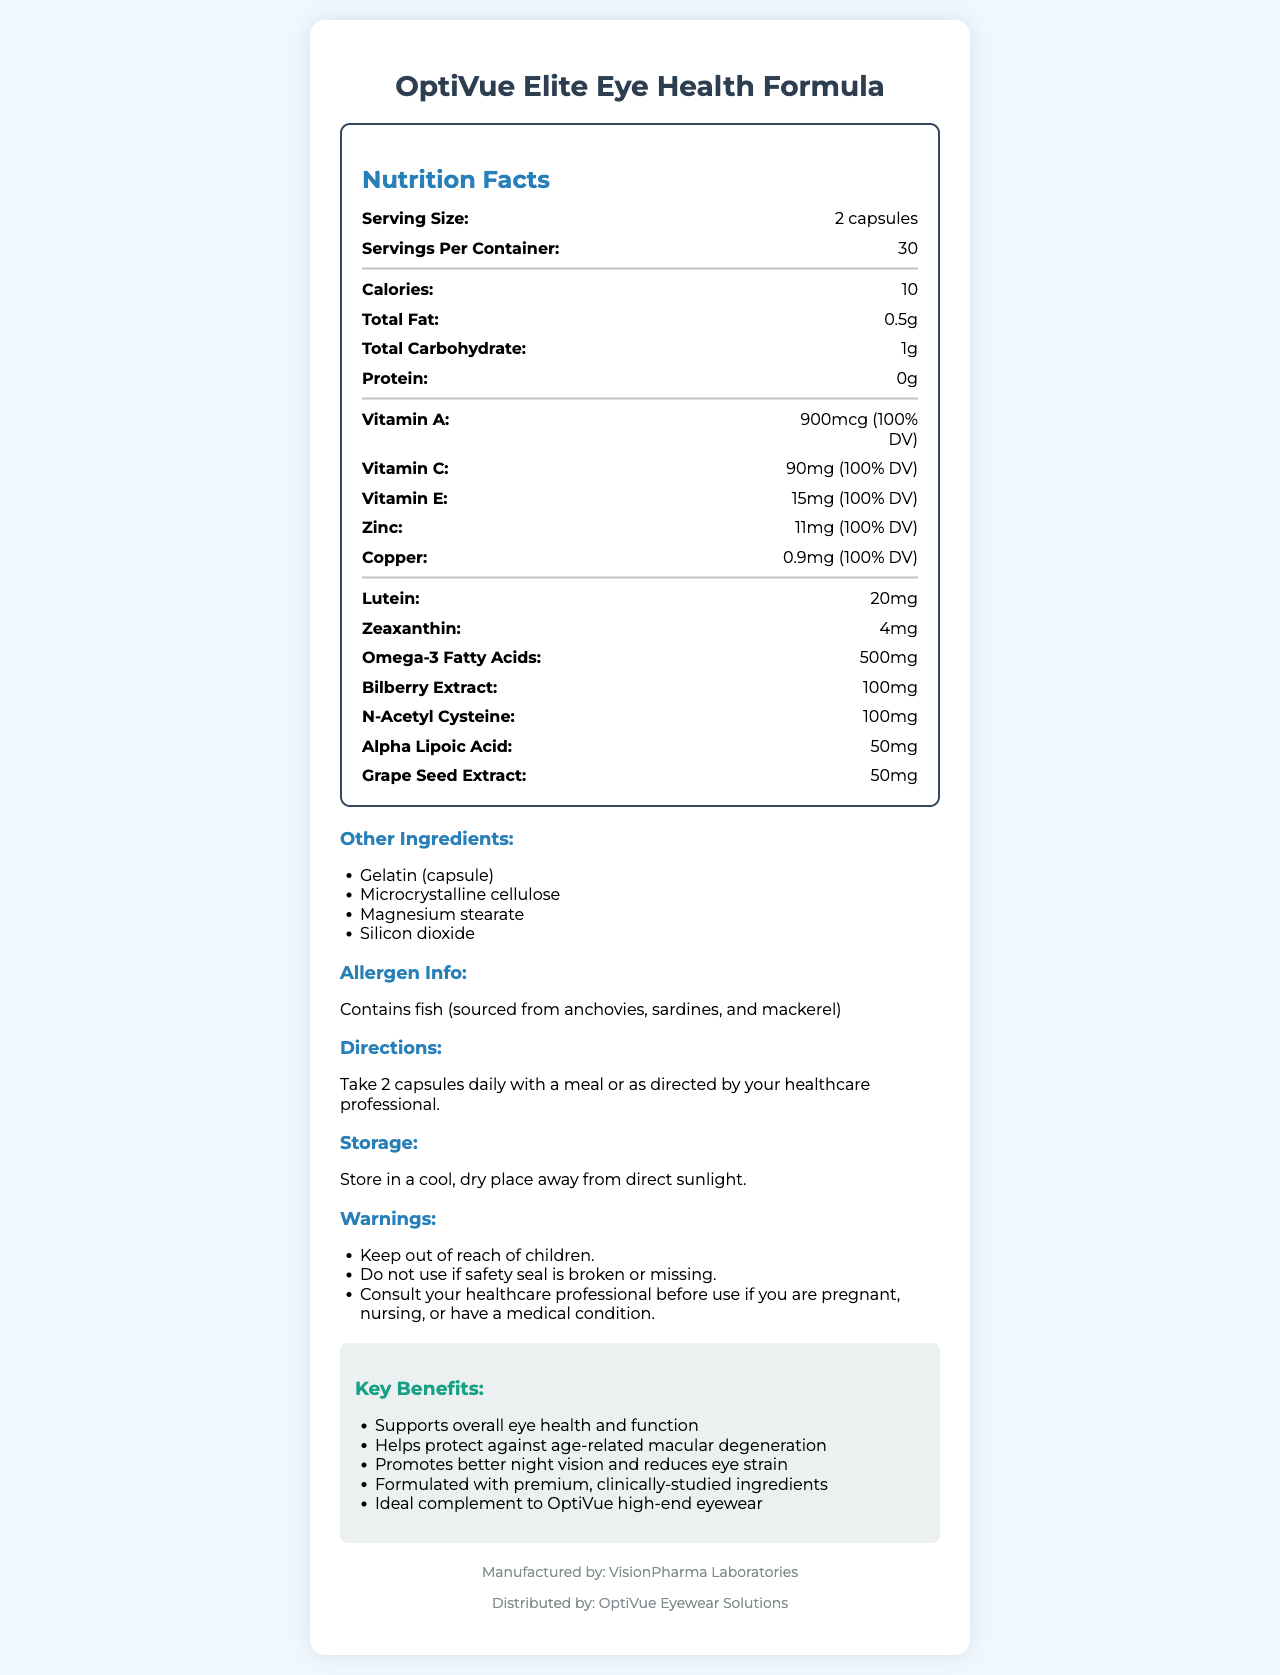what is the serving size? The document states that the serving size for OptiVue Elite Eye Health Formula is 2 capsules.
Answer: 2 capsules how many servings are in a container? According to the document, there are 30 servings per container of OptiVue Elite Eye Health Formula.
Answer: 30 what is the total amount of omega-3 fatty acids per serving? The nutrition facts mention that each serving contains 500mg of omega-3 fatty acids.
Answer: 500mg how many calories are in a serving? The document specifies that there are 10 calories per serving.
Answer: 10 what percentage of the Daily Value does the Vitamin A content represent? The document lists the Vitamin A content as 900mcg, which is 100% of the Daily Value.
Answer: 100% which ingredients are specifically associated with eye health in the product? The ingredients specifically associated with eye health listed in the document are Lutein (20mg) and Zeaxanthin (4mg).
Answer: Lutein, Zeaxanthin which vitamin has the highest amount per serving in milligrams? Vitamin C has 90mg per serving, which is the highest amount compared to the other vitamins listed.
Answer: Vitamin C what are the directions for using this supplement? The document indicates that the users should take 2 capsules daily with a meal or as directed by their healthcare professional.
Answer: Take 2 capsules daily with a meal or as directed by your healthcare professional. what is the main allergen present in the product? The allergen information section states that the product contains fish, sourced from anchovies, sardines, and mackerel.
Answer: Fish (sourced from anchovies, sardines, and mackerel) summarize the key benefits of the OptiVue Elite Eye Health Formula. The key benefits listed in the document demonstrate that this supplement supports overall eye health, helps protect against age-related macular degeneration, promotes better night vision, reduces eye strain, and is formulated with premium ingredients.
Answer: Supports overall eye health and function, helps protect against age-related macular degeneration, promotes better night vision and reduces eye strain, formulated with premium, clinically-studied ingredients, ideal complement to OptiVue high-end eyewear who manufactures the OptiVue Elite Eye Health Formula? The footer of the document states that VisionPharma Laboratories manufactures the product.
Answer: VisionPharma Laboratories what other ingredients are included in this supplement (excluding main nutrients and key ingredients)? The "Other Ingredients" section lists Gelatin (capsule), Microcrystalline cellulose, Magnesium stearate, and Silicon dioxide.
Answer: Gelatin (capsule), Microcrystalline cellulose, Magnesium stearate, Silicon dioxide what two minerals are present in the OptiVue Elite Eye Health Formula? 
A. Iron and Calcium
B. Zinc and Copper
C. Magnesium and Potassium 
D. Sodium and Phosphorus The document lists Zinc and Copper as minerals included in the formula, whereas Iron, Calcium, Magnesium, Potassium, Sodium, and Phosphorus are not mentioned.
Answer: B. Zinc and Copper what is the storage recommendation for this supplement?
A. Store in a freezer
B. Store at room temperature
C. Store in a cool, dry place away from direct sunlight
D. Store in the refrigerator The storage instructions in the document recommend storing the supplement in a cool, dry place away from direct sunlight.
Answer: C. Store in a cool, dry place away from direct sunlight is this supplement suitable for children? The document clearly states a warning to keep the product out of reach of children.
Answer: No why might someone need to consult their healthcare professional before using this supplement? The warnings advise consulting a healthcare professional before use if you are pregnant, nursing, or have a medical condition.
Answer: People who are pregnant, nursing, or have a medical condition. what is the purpose of the provided list of marketing claims? The marketing claims section is designed to emphasize the advantages and potential efficacy of the OptiVue Elite Eye Health Formula for promoting eye health.
Answer: To highlight the benefits and effectiveness of the supplement for which specific condition does OptiVue Elite Eye Health Formula help provide protection? One of the marketing claims mentions that the formula helps protect against age-related macular degeneration.
Answer: Age-related macular degeneration what is the name of the product's distributor? According to the document, OptiVue Eyewear Solutions distributes the product.
Answer: OptiVue Eyewear Solutions what is the exact formula for determining the Daily Value percentages of vitamins? The document provides the Daily Value percentages for the specific vitamins but does not detail the formula used to calculate these percentages.
Answer: Cannot be determined 